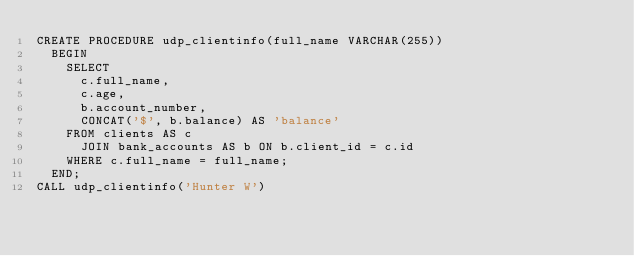<code> <loc_0><loc_0><loc_500><loc_500><_SQL_>CREATE PROCEDURE udp_clientinfo(full_name VARCHAR(255))
  BEGIN
    SELECT
      c.full_name,
      c.age,
      b.account_number,
      CONCAT('$', b.balance) AS 'balance'
    FROM clients AS c
      JOIN bank_accounts AS b ON b.client_id = c.id
    WHERE c.full_name = full_name;
  END;
CALL udp_clientinfo('Hunter W')</code> 